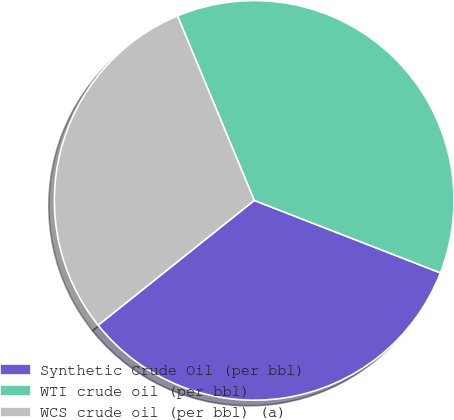<chart> <loc_0><loc_0><loc_500><loc_500><pie_chart><fcel>Synthetic Crude Oil (per bbl)<fcel>WTI crude oil (per bbl)<fcel>WCS crude oil (per bbl) (a)<nl><fcel>33.36%<fcel>37.18%<fcel>29.46%<nl></chart> 